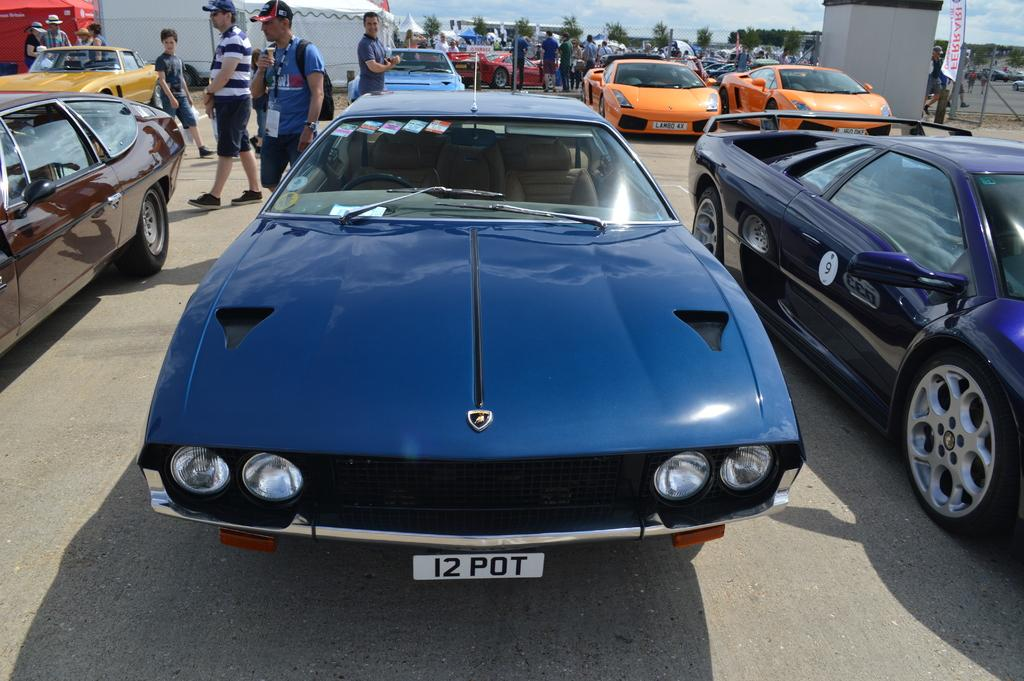What is happening on the road in the image? There are vehicles on the road in the image. What can be seen in the background of the image? In the background of the image, there are persons standing and walking, tents, poles, banners, trees, and clouds visible in the sky. What type of pump is being used to extract poison from the trees in the image? There is no pump or poison present in the image; it features vehicles on the road and various elements in the background. 